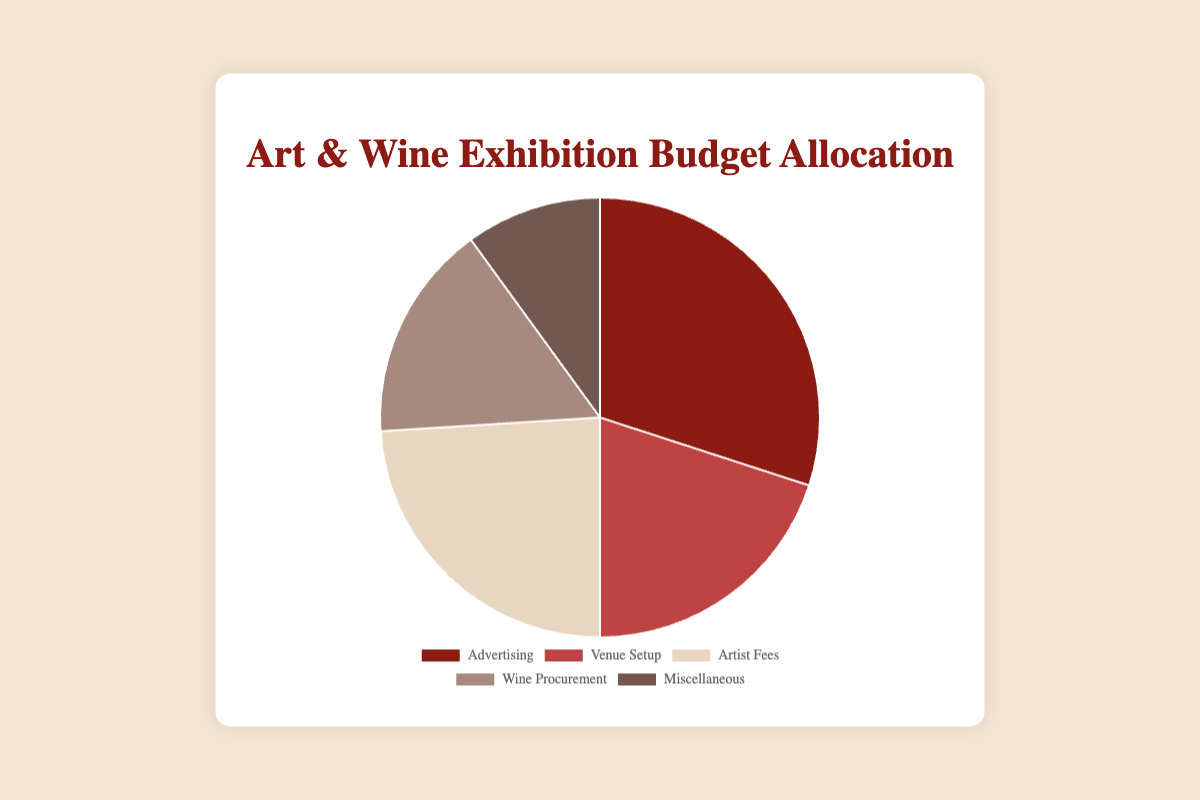What is the largest allocation in the budget? The largest section in the pie chart represents the one with the highest value. By comparing the sizes of the sections, you can identify that "Advertising" is the largest.
Answer: Advertising How much more is allocated to Artist Fees than to Wine Procurement? The value for Artist Fees is $12,000, and for Wine Procurement is $8,000. The difference is calculated by subtracting the two values: $12,000 - $8,000.
Answer: $4,000 Which category has the smallest budget allocation? By looking at the pie chart, the smallest section corresponds to the smallest value, which is "Miscellaneous" with $5,000.
Answer: Miscellaneous What is the sum of the allocations for Venue Setup and Miscellaneous? Add the allocations for Venue Setup ($10,000) and Miscellaneous ($5,000): $10,000 + $5,000.
Answer: $15,000 Which two categories together make up more than $20,000? By evaluating combinations: "Advertising" ($15,000) and "Artist Fees" ($12,000) together make $27,000, which is more than $20,000.
Answer: Advertising and Artist Fees How does the budget for Wine Procurement compare to the budget for Advertising? The budget for Wine Procurement is $8,000, and for Advertising it's $15,000. The Advertising budget is larger.
Answer: Advertising is larger What percentage of the total budget is allocated to Advertising? Calculate the total budget sum: $15,000 + $10,000 + $12,000 + $8,000 + $5,000 = $50,000. The percentage for Advertising is ($15,000 / $50,000) * 100%.
Answer: 30% Is the allocation for Venue Setup larger or smaller than the allocation for Artist Fees? Compare the values: Venue Setup is $10,000, and Artist Fees is $12,000. Venue Setup is smaller.
Answer: Smaller If you combined the budgets for Advertising and Wine Procurement, would it be more than half of the total budget? Advertising ($15,000) + Wine Procurement ($8,000) = $23,000. Half of the total budget is $25,000. $23,000 is less than $25,000.
Answer: No, it would not Which section of the pie chart is represented by a dark red color? Identify the colors visually; the dark red color corresponds to "Advertising".
Answer: Advertising 